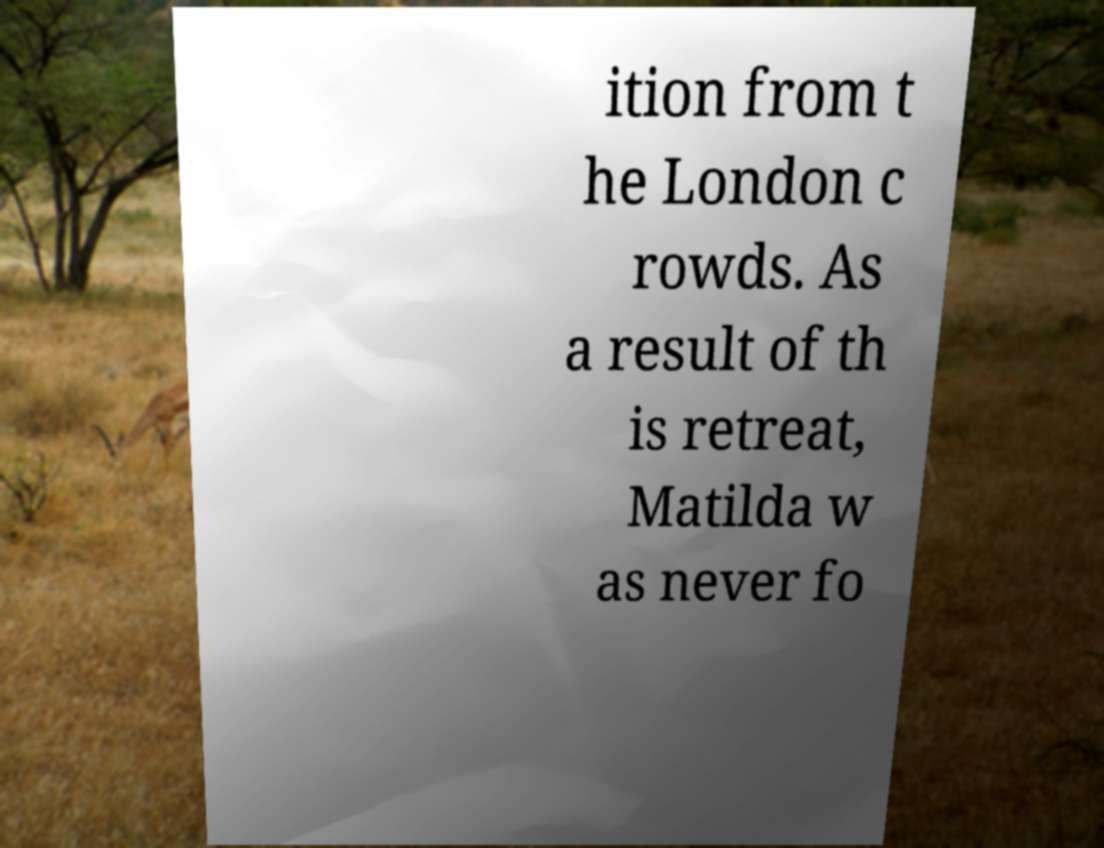What messages or text are displayed in this image? I need them in a readable, typed format. ition from t he London c rowds. As a result of th is retreat, Matilda w as never fo 